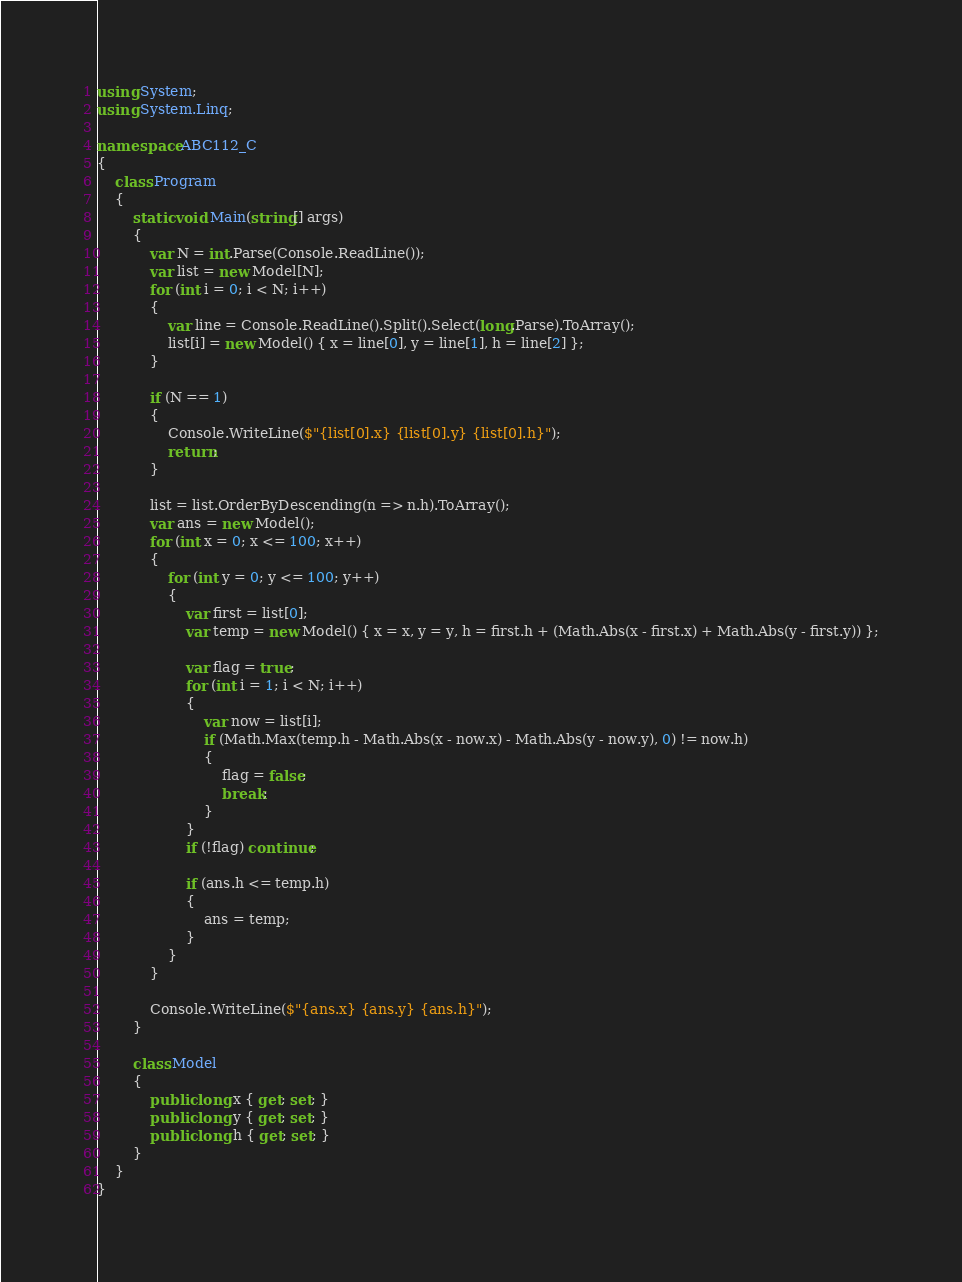<code> <loc_0><loc_0><loc_500><loc_500><_C#_>using System;
using System.Linq;

namespace ABC112_C
{
    class Program
    {
        static void Main(string[] args)
        {
            var N = int.Parse(Console.ReadLine());
            var list = new Model[N];
            for (int i = 0; i < N; i++)
            {
                var line = Console.ReadLine().Split().Select(long.Parse).ToArray();
                list[i] = new Model() { x = line[0], y = line[1], h = line[2] };
            }

            if (N == 1)
            {
                Console.WriteLine($"{list[0].x} {list[0].y} {list[0].h}");
                return;
            }

            list = list.OrderByDescending(n => n.h).ToArray();
            var ans = new Model();
            for (int x = 0; x <= 100; x++)
            {
                for (int y = 0; y <= 100; y++)
                {
                    var first = list[0];
                    var temp = new Model() { x = x, y = y, h = first.h + (Math.Abs(x - first.x) + Math.Abs(y - first.y)) };

                    var flag = true;
                    for (int i = 1; i < N; i++)
                    {
                        var now = list[i];
                        if (Math.Max(temp.h - Math.Abs(x - now.x) - Math.Abs(y - now.y), 0) != now.h)
                        {
                            flag = false;
                            break;
                        }
                    }
                    if (!flag) continue;

                    if (ans.h <= temp.h)
                    {
                        ans = temp;
                    }
                }
            }

            Console.WriteLine($"{ans.x} {ans.y} {ans.h}");
        }

        class Model
        {
            public long x { get; set; }
            public long y { get; set; }
            public long h { get; set; }
        }
    }
}
</code> 